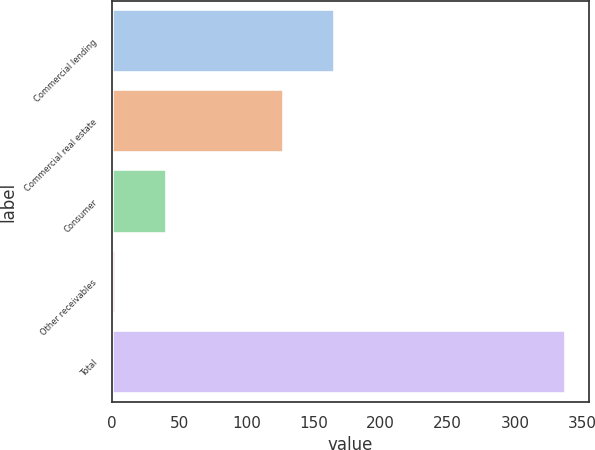<chart> <loc_0><loc_0><loc_500><loc_500><bar_chart><fcel>Commercial lending<fcel>Commercial real estate<fcel>Consumer<fcel>Other receivables<fcel>Total<nl><fcel>166<fcel>128<fcel>41<fcel>3<fcel>338<nl></chart> 